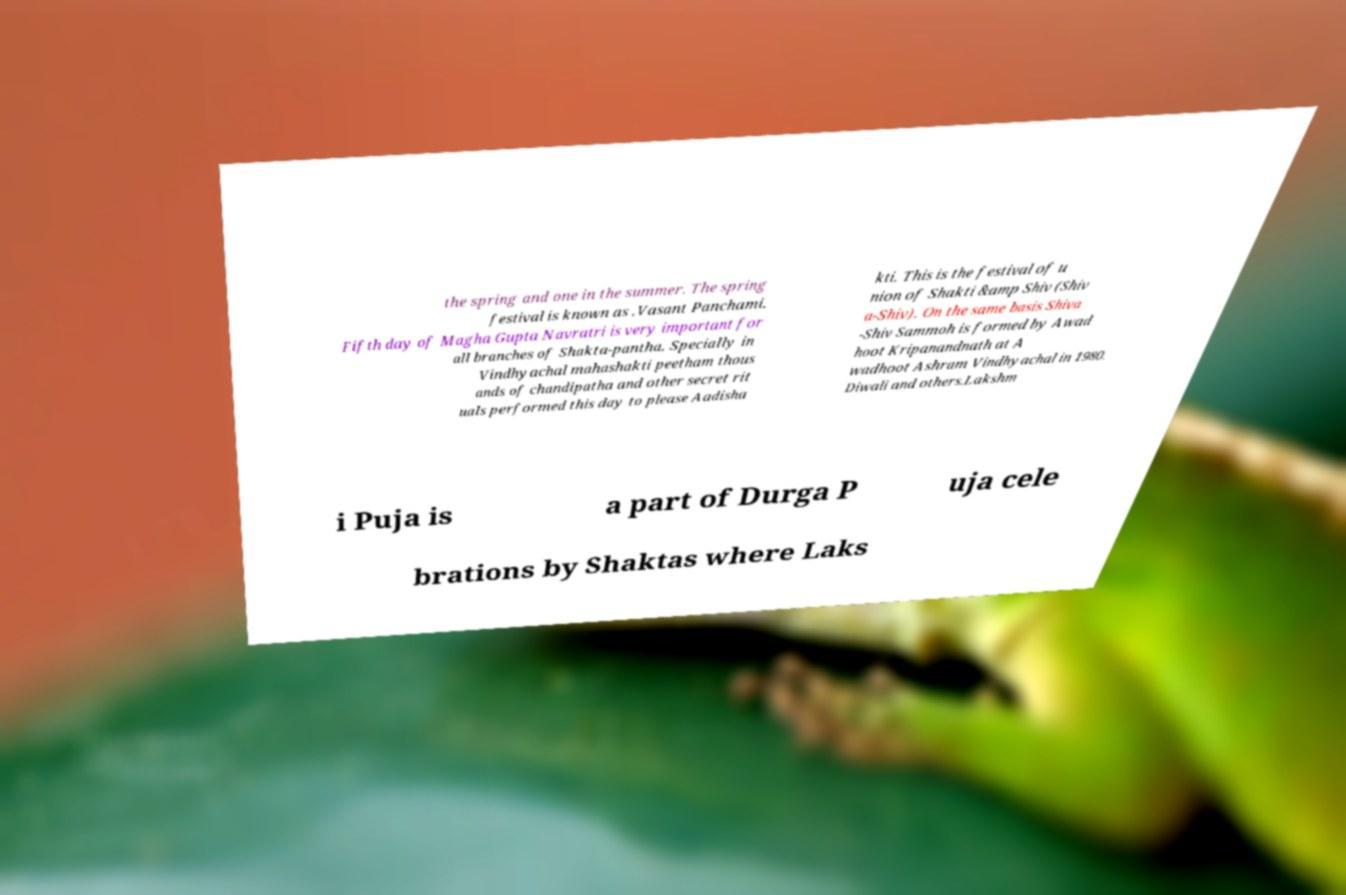Please read and relay the text visible in this image. What does it say? the spring and one in the summer. The spring festival is known as .Vasant Panchami. Fifth day of Magha Gupta Navratri is very important for all branches of Shakta-pantha. Specially in Vindhyachal mahashakti peetham thous ands of chandipatha and other secret rit uals performed this day to please Aadisha kti. This is the festival of u nion of Shakti &amp Shiv (Shiv a-Shiv). On the same basis Shiva -Shiv Sammoh is formed by Awad hoot Kripanandnath at A wadhoot Ashram Vindhyachal in 1980. Diwali and others.Lakshm i Puja is a part of Durga P uja cele brations by Shaktas where Laks 